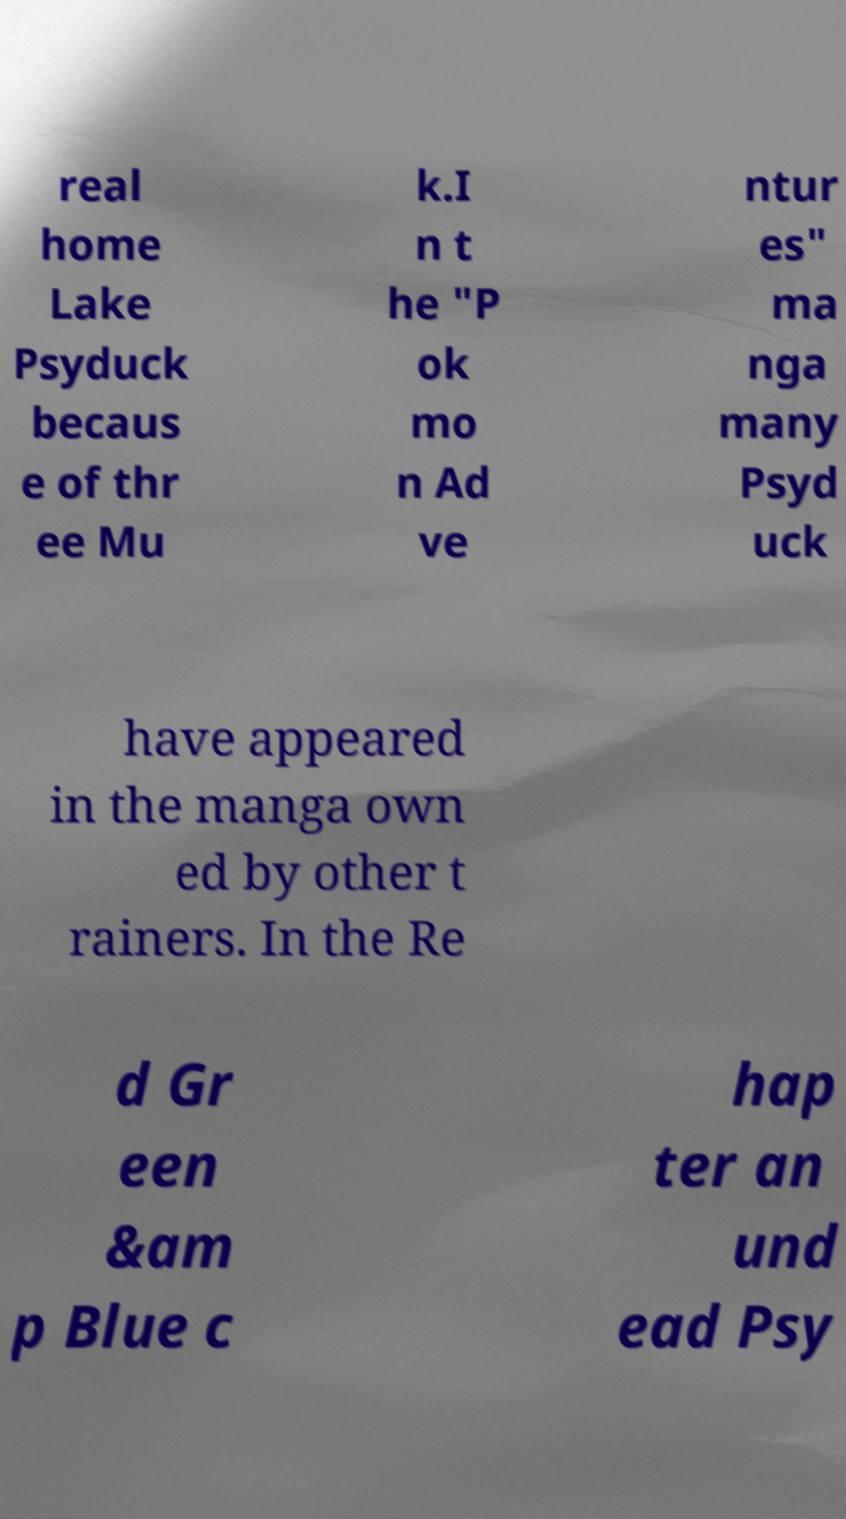What messages or text are displayed in this image? I need them in a readable, typed format. real home Lake Psyduck becaus e of thr ee Mu k.I n t he "P ok mo n Ad ve ntur es" ma nga many Psyd uck have appeared in the manga own ed by other t rainers. In the Re d Gr een &am p Blue c hap ter an und ead Psy 